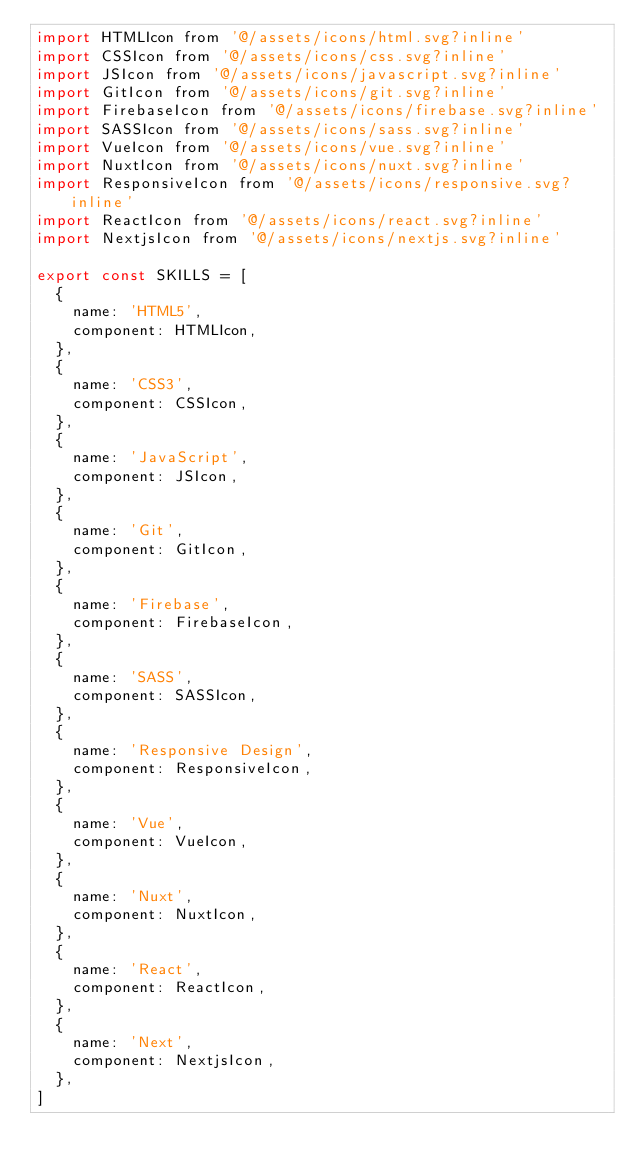Convert code to text. <code><loc_0><loc_0><loc_500><loc_500><_JavaScript_>import HTMLIcon from '@/assets/icons/html.svg?inline'
import CSSIcon from '@/assets/icons/css.svg?inline'
import JSIcon from '@/assets/icons/javascript.svg?inline'
import GitIcon from '@/assets/icons/git.svg?inline'
import FirebaseIcon from '@/assets/icons/firebase.svg?inline'
import SASSIcon from '@/assets/icons/sass.svg?inline'
import VueIcon from '@/assets/icons/vue.svg?inline'
import NuxtIcon from '@/assets/icons/nuxt.svg?inline'
import ResponsiveIcon from '@/assets/icons/responsive.svg?inline'
import ReactIcon from '@/assets/icons/react.svg?inline'
import NextjsIcon from '@/assets/icons/nextjs.svg?inline'

export const SKILLS = [
  {
    name: 'HTML5',
    component: HTMLIcon,
  },
  {
    name: 'CSS3',
    component: CSSIcon,
  },
  {
    name: 'JavaScript',
    component: JSIcon,
  },
  {
    name: 'Git',
    component: GitIcon,
  },
  {
    name: 'Firebase',
    component: FirebaseIcon,
  },
  {
    name: 'SASS',
    component: SASSIcon,
  },
  {
    name: 'Responsive Design',
    component: ResponsiveIcon,
  },
  {
    name: 'Vue',
    component: VueIcon,
  },
  {
    name: 'Nuxt',
    component: NuxtIcon,
  },
  {
    name: 'React',
    component: ReactIcon,
  },
  {
    name: 'Next',
    component: NextjsIcon,
  },
]
</code> 